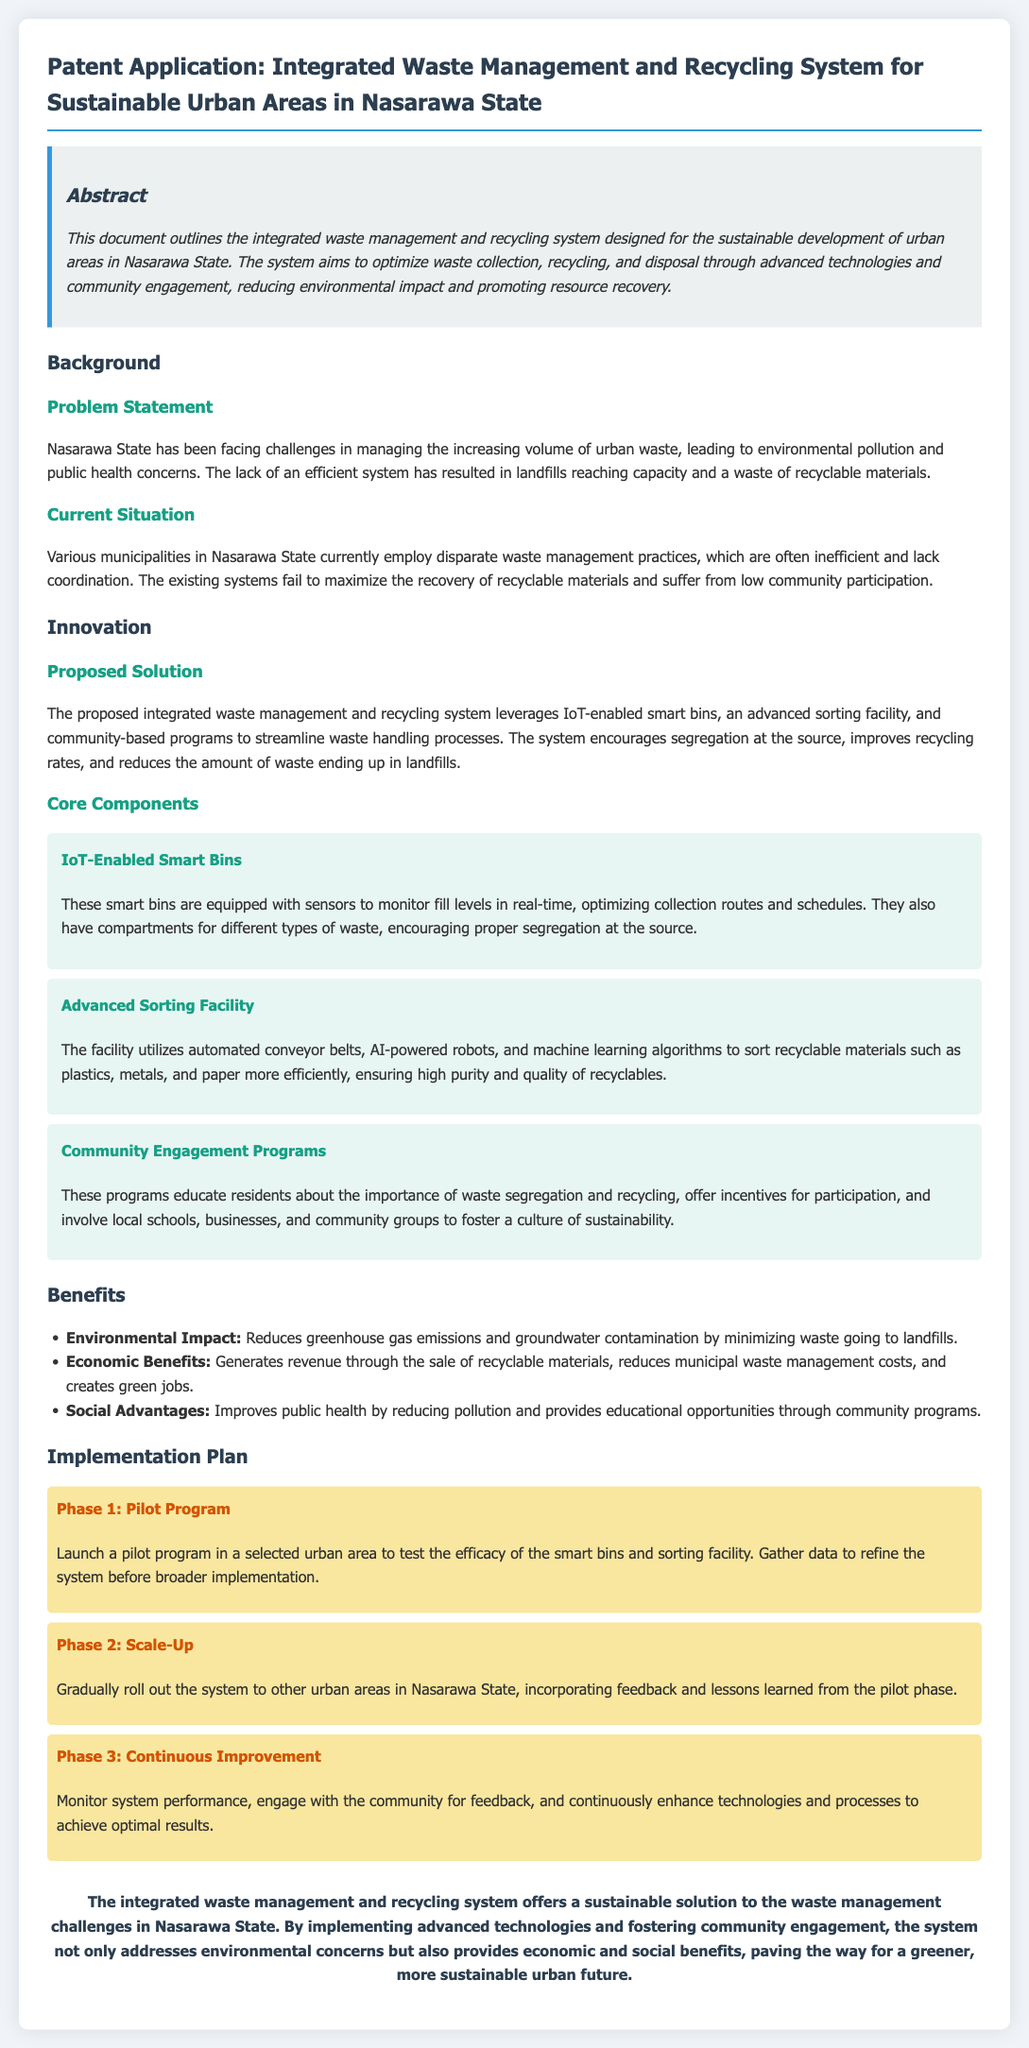What is the title of the patent application? The title of the patent application is found in the header section of the document.
Answer: Integrated Waste Management and Recycling System for Sustainable Urban Areas in Nasarawa State What does the system aim to optimize? The document specifies the main goals of the system in the abstract section.
Answer: Waste collection, recycling, and disposal What is one of the core components of the proposed solution? The core components are listed in the innovation section, detailing the technology used.
Answer: IoT-Enabled Smart Bins What are the economic benefits mentioned? The benefits are outlined under the benefits section, highlighting multiple positive effects.
Answer: Generates revenue through the sale of recyclable materials How many phases are in the implementation plan? The phases are detailed in the implementation plan section, indicating the approach to roll out the project.
Answer: Three What is the primary problem addressed by the proposed system? This can be found in the background section, specifically in the problem statement.
Answer: Increasing volume of urban waste What type of technologies does the system leverage? The type of technologies is mentioned in the proposed solution section.
Answer: IoT-enabled smart bins What is the main purpose of community engagement programs? The purpose is outlined within the core components, explaining the intent of these programs.
Answer: Educate residents about the importance of waste segregation and recycling What is the expected outcome of Phase 1? The expected outcomes are described in the implementation plan's first phase section.
Answer: Test the efficacy of the smart bins and sorting facility 